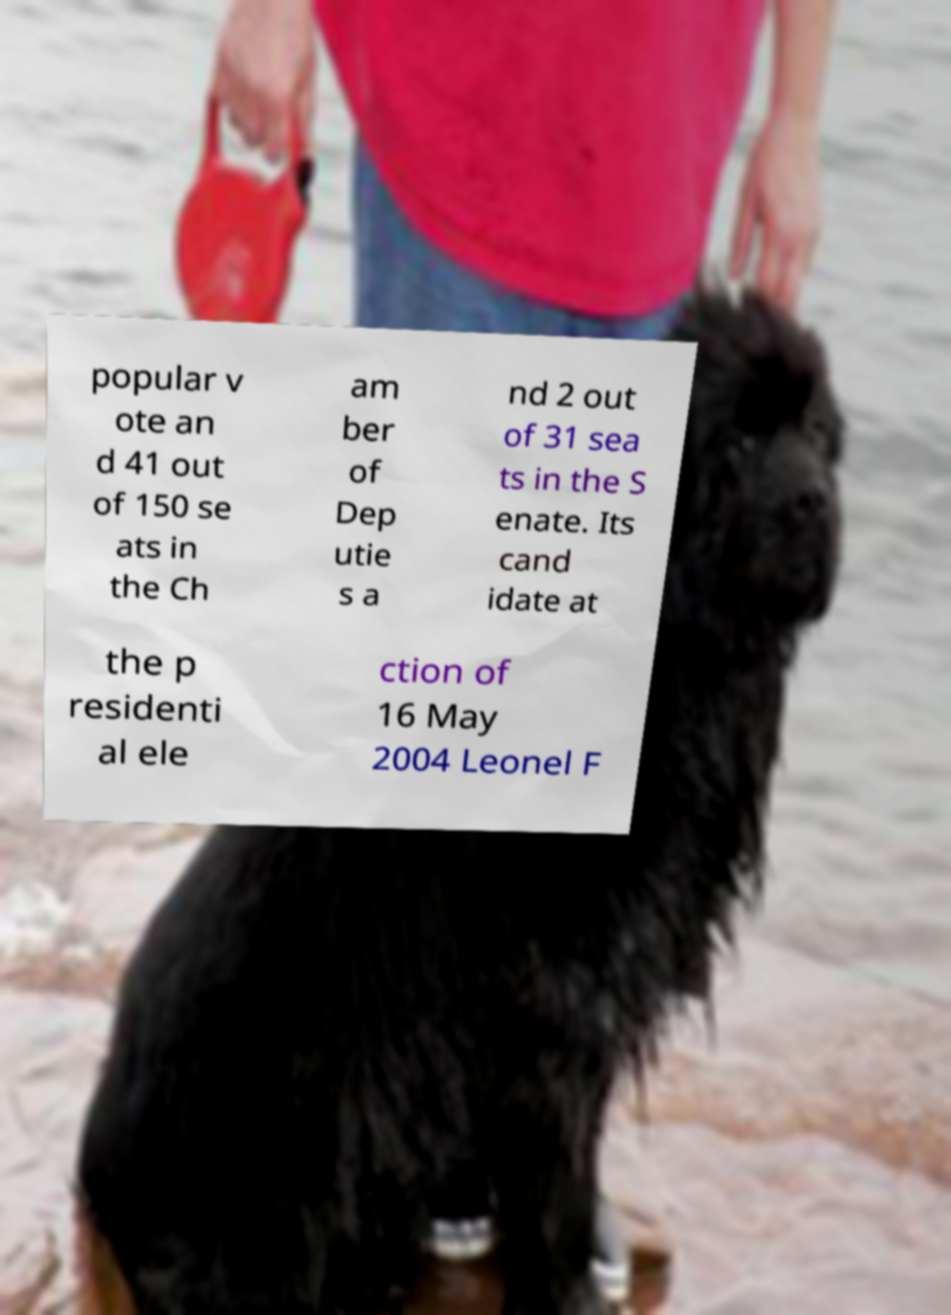Please identify and transcribe the text found in this image. popular v ote an d 41 out of 150 se ats in the Ch am ber of Dep utie s a nd 2 out of 31 sea ts in the S enate. Its cand idate at the p residenti al ele ction of 16 May 2004 Leonel F 